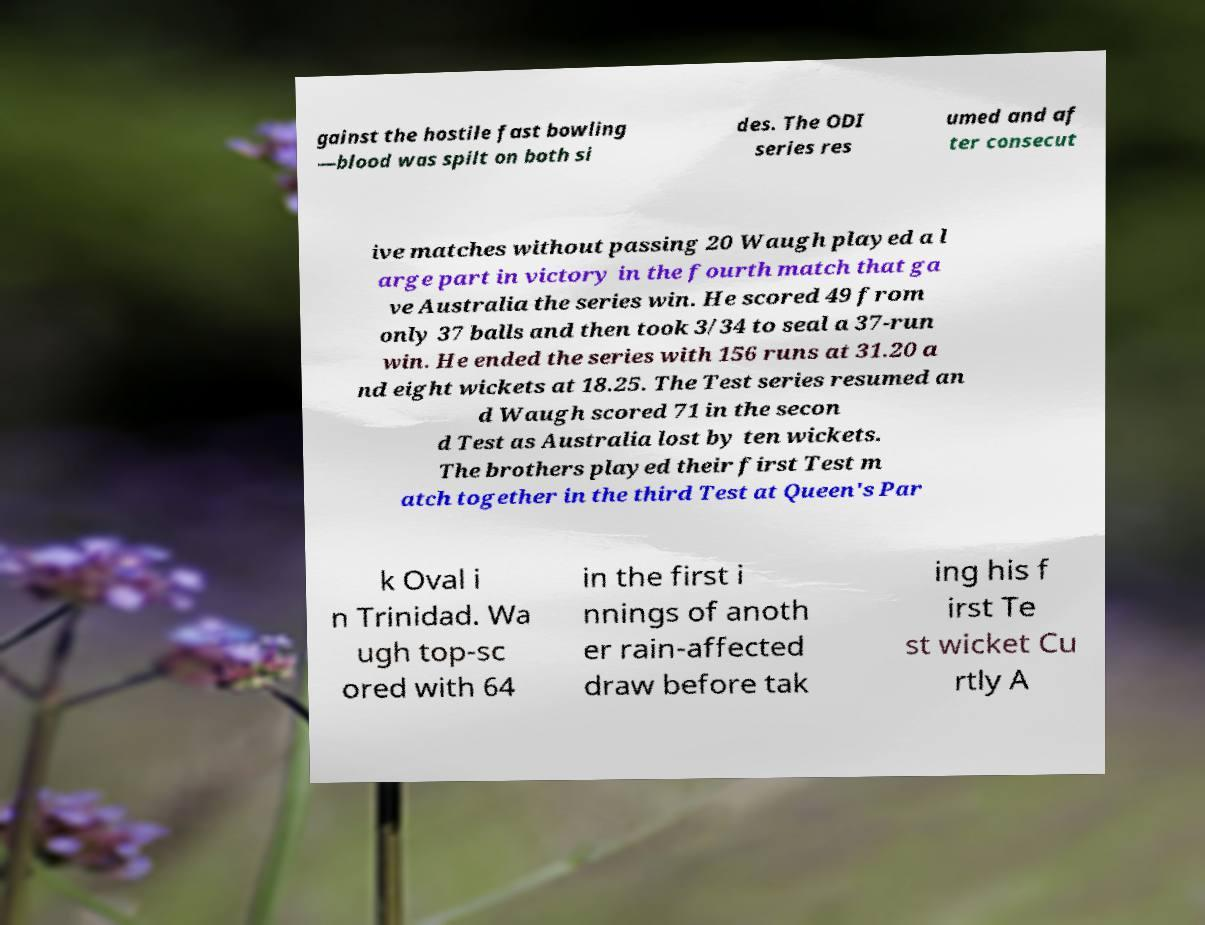What messages or text are displayed in this image? I need them in a readable, typed format. gainst the hostile fast bowling —blood was spilt on both si des. The ODI series res umed and af ter consecut ive matches without passing 20 Waugh played a l arge part in victory in the fourth match that ga ve Australia the series win. He scored 49 from only 37 balls and then took 3/34 to seal a 37-run win. He ended the series with 156 runs at 31.20 a nd eight wickets at 18.25. The Test series resumed an d Waugh scored 71 in the secon d Test as Australia lost by ten wickets. The brothers played their first Test m atch together in the third Test at Queen's Par k Oval i n Trinidad. Wa ugh top-sc ored with 64 in the first i nnings of anoth er rain-affected draw before tak ing his f irst Te st wicket Cu rtly A 